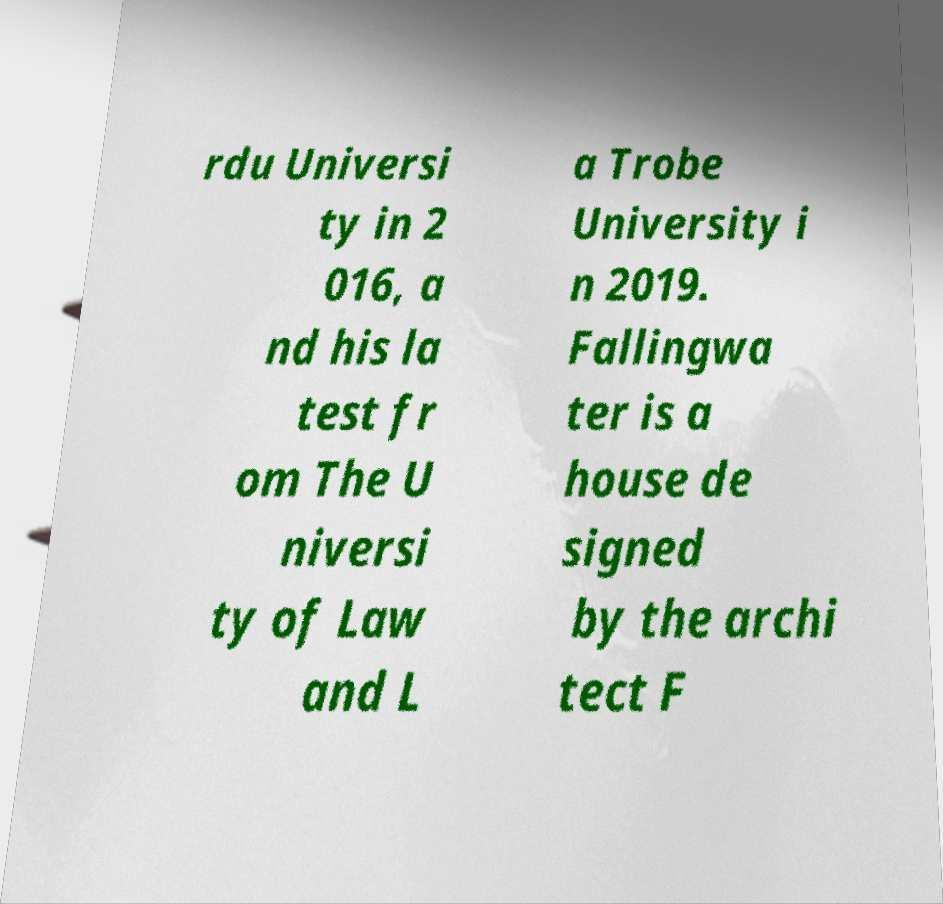Please read and relay the text visible in this image. What does it say? rdu Universi ty in 2 016, a nd his la test fr om The U niversi ty of Law and L a Trobe University i n 2019. Fallingwa ter is a house de signed by the archi tect F 